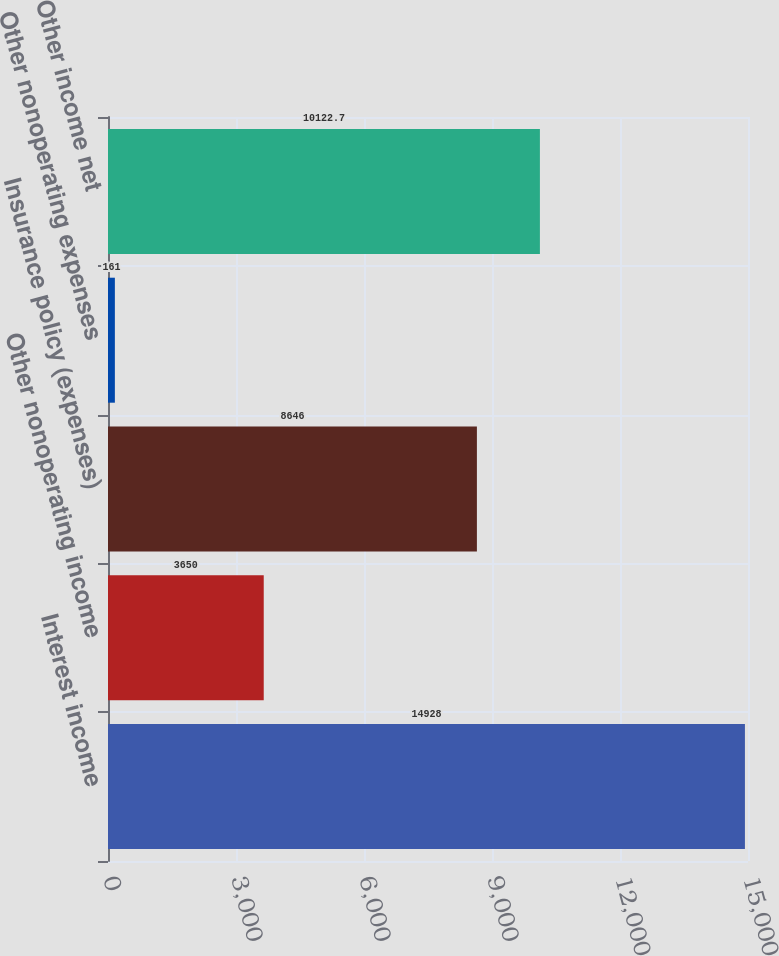Convert chart. <chart><loc_0><loc_0><loc_500><loc_500><bar_chart><fcel>Interest income<fcel>Other nonoperating income<fcel>Insurance policy (expenses)<fcel>Other nonoperating expenses<fcel>Other income net<nl><fcel>14928<fcel>3650<fcel>8646<fcel>161<fcel>10122.7<nl></chart> 